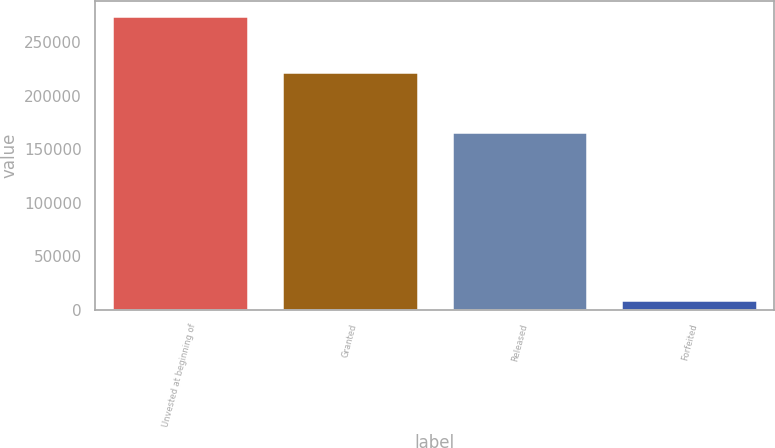<chart> <loc_0><loc_0><loc_500><loc_500><bar_chart><fcel>Unvested at beginning of<fcel>Granted<fcel>Released<fcel>Forfeited<nl><fcel>275000<fcel>222683<fcel>166250<fcel>9000<nl></chart> 